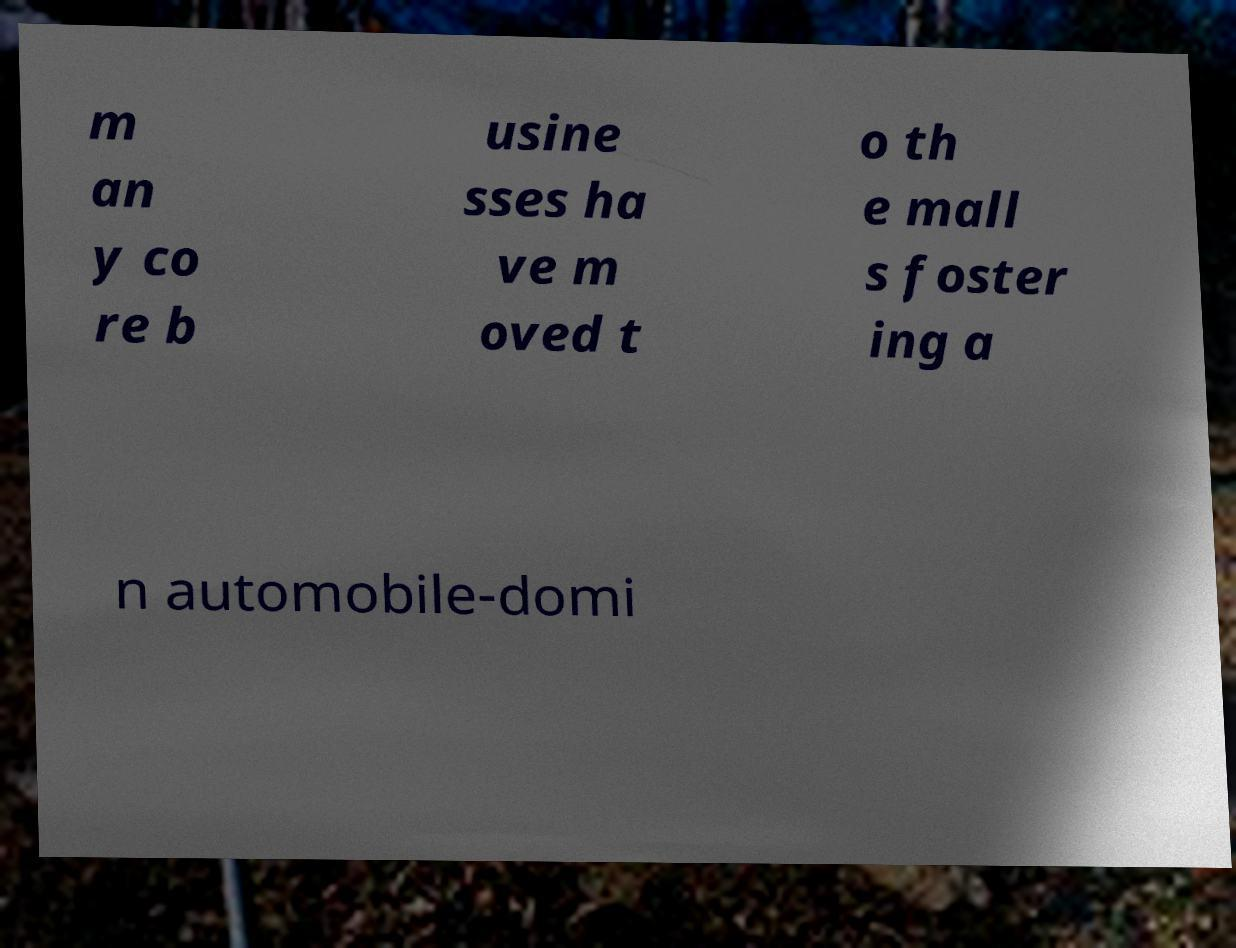Please identify and transcribe the text found in this image. m an y co re b usine sses ha ve m oved t o th e mall s foster ing a n automobile-domi 